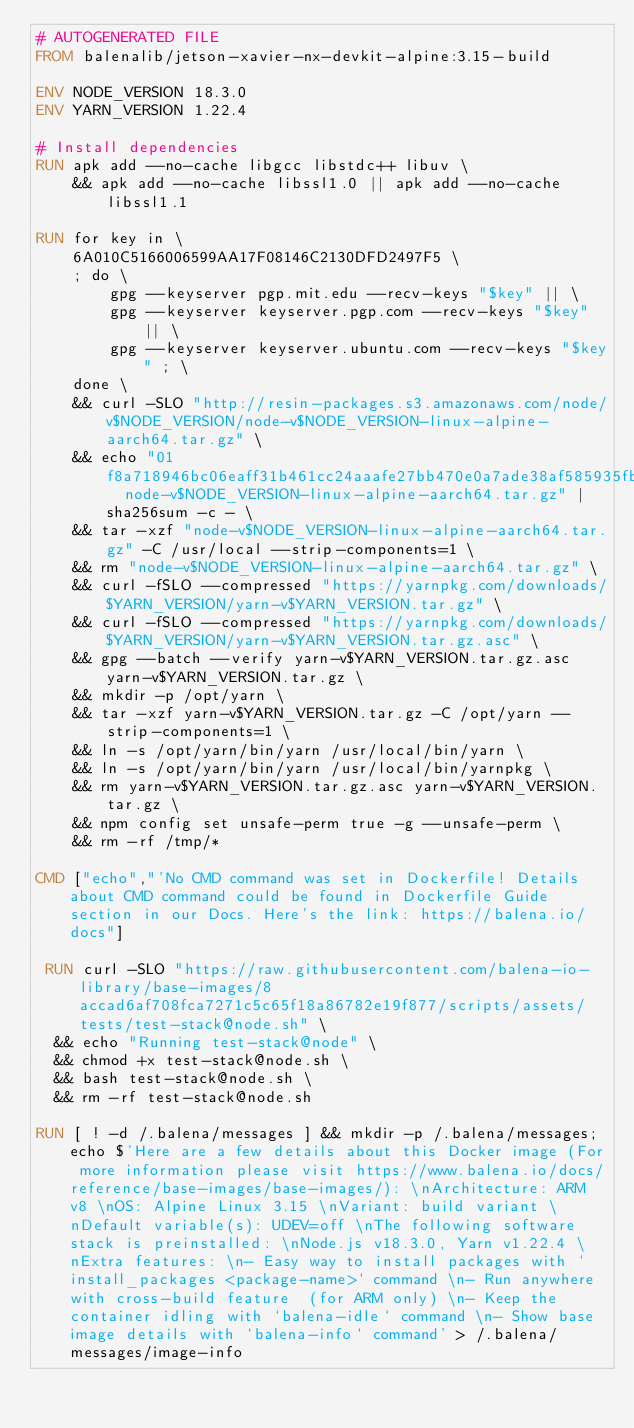<code> <loc_0><loc_0><loc_500><loc_500><_Dockerfile_># AUTOGENERATED FILE
FROM balenalib/jetson-xavier-nx-devkit-alpine:3.15-build

ENV NODE_VERSION 18.3.0
ENV YARN_VERSION 1.22.4

# Install dependencies
RUN apk add --no-cache libgcc libstdc++ libuv \
	&& apk add --no-cache libssl1.0 || apk add --no-cache libssl1.1

RUN for key in \
	6A010C5166006599AA17F08146C2130DFD2497F5 \
	; do \
		gpg --keyserver pgp.mit.edu --recv-keys "$key" || \
		gpg --keyserver keyserver.pgp.com --recv-keys "$key" || \
		gpg --keyserver keyserver.ubuntu.com --recv-keys "$key" ; \
	done \
	&& curl -SLO "http://resin-packages.s3.amazonaws.com/node/v$NODE_VERSION/node-v$NODE_VERSION-linux-alpine-aarch64.tar.gz" \
	&& echo "01f8a718946bc06eaff31b461cc24aaafe27bb470e0a7ade38af585935fbd503  node-v$NODE_VERSION-linux-alpine-aarch64.tar.gz" | sha256sum -c - \
	&& tar -xzf "node-v$NODE_VERSION-linux-alpine-aarch64.tar.gz" -C /usr/local --strip-components=1 \
	&& rm "node-v$NODE_VERSION-linux-alpine-aarch64.tar.gz" \
	&& curl -fSLO --compressed "https://yarnpkg.com/downloads/$YARN_VERSION/yarn-v$YARN_VERSION.tar.gz" \
	&& curl -fSLO --compressed "https://yarnpkg.com/downloads/$YARN_VERSION/yarn-v$YARN_VERSION.tar.gz.asc" \
	&& gpg --batch --verify yarn-v$YARN_VERSION.tar.gz.asc yarn-v$YARN_VERSION.tar.gz \
	&& mkdir -p /opt/yarn \
	&& tar -xzf yarn-v$YARN_VERSION.tar.gz -C /opt/yarn --strip-components=1 \
	&& ln -s /opt/yarn/bin/yarn /usr/local/bin/yarn \
	&& ln -s /opt/yarn/bin/yarn /usr/local/bin/yarnpkg \
	&& rm yarn-v$YARN_VERSION.tar.gz.asc yarn-v$YARN_VERSION.tar.gz \
	&& npm config set unsafe-perm true -g --unsafe-perm \
	&& rm -rf /tmp/*

CMD ["echo","'No CMD command was set in Dockerfile! Details about CMD command could be found in Dockerfile Guide section in our Docs. Here's the link: https://balena.io/docs"]

 RUN curl -SLO "https://raw.githubusercontent.com/balena-io-library/base-images/8accad6af708fca7271c5c65f18a86782e19f877/scripts/assets/tests/test-stack@node.sh" \
  && echo "Running test-stack@node" \
  && chmod +x test-stack@node.sh \
  && bash test-stack@node.sh \
  && rm -rf test-stack@node.sh 

RUN [ ! -d /.balena/messages ] && mkdir -p /.balena/messages; echo $'Here are a few details about this Docker image (For more information please visit https://www.balena.io/docs/reference/base-images/base-images/): \nArchitecture: ARM v8 \nOS: Alpine Linux 3.15 \nVariant: build variant \nDefault variable(s): UDEV=off \nThe following software stack is preinstalled: \nNode.js v18.3.0, Yarn v1.22.4 \nExtra features: \n- Easy way to install packages with `install_packages <package-name>` command \n- Run anywhere with cross-build feature  (for ARM only) \n- Keep the container idling with `balena-idle` command \n- Show base image details with `balena-info` command' > /.balena/messages/image-info</code> 